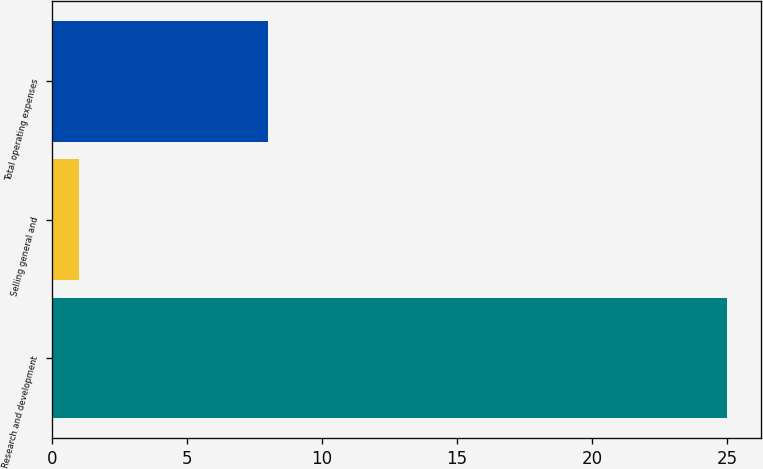<chart> <loc_0><loc_0><loc_500><loc_500><bar_chart><fcel>Research and development<fcel>Selling general and<fcel>Total operating expenses<nl><fcel>25<fcel>1<fcel>8<nl></chart> 